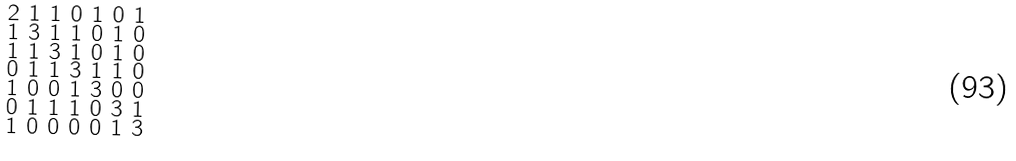Convert formula to latex. <formula><loc_0><loc_0><loc_500><loc_500>\begin{smallmatrix} 2 & 1 & 1 & 0 & 1 & 0 & 1 \\ 1 & 3 & 1 & 1 & 0 & 1 & 0 \\ 1 & 1 & 3 & 1 & 0 & 1 & 0 \\ 0 & 1 & 1 & 3 & 1 & 1 & 0 \\ 1 & 0 & 0 & 1 & 3 & 0 & 0 \\ 0 & 1 & 1 & 1 & 0 & 3 & 1 \\ 1 & 0 & 0 & 0 & 0 & 1 & 3 \end{smallmatrix}</formula> 